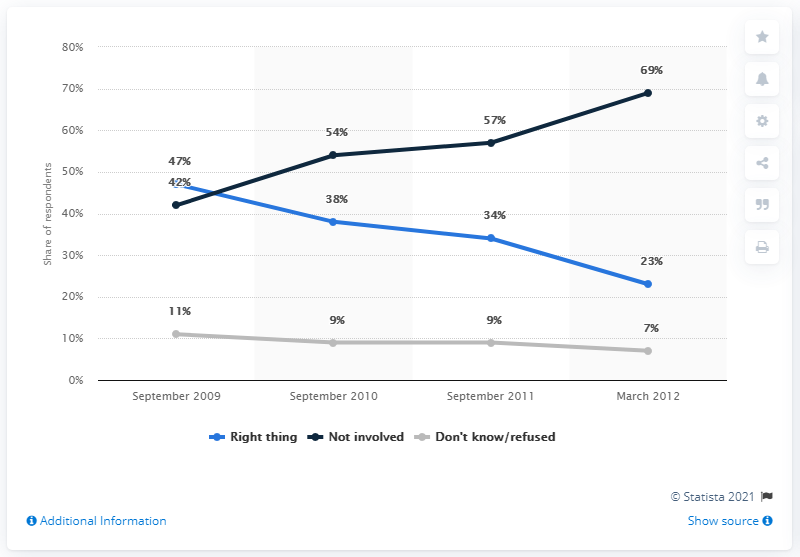Specify some key components in this picture. The difference between the highest and lowest values of "Not involved" respondents is 27. In September 2009, the percentage value of doing the right thing was 47%. 